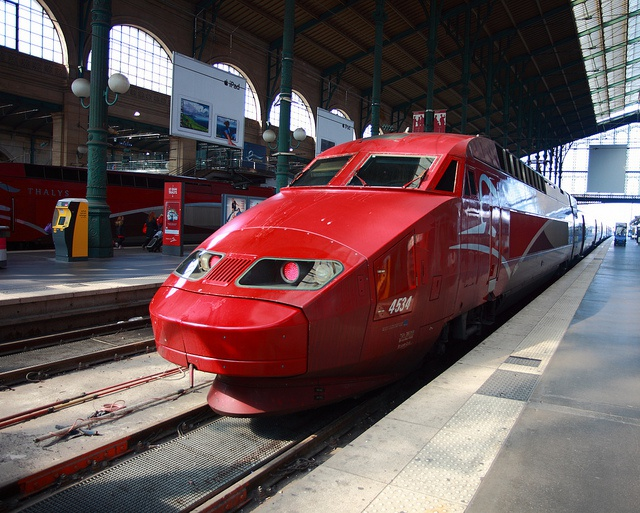Describe the objects in this image and their specific colors. I can see train in violet, maroon, red, black, and salmon tones, train in violet, black, blue, and gray tones, people in violet, black, and maroon tones, people in violet, black, maroon, brown, and gray tones, and suitcase in violet, black, and purple tones in this image. 